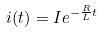Convert formula to latex. <formula><loc_0><loc_0><loc_500><loc_500>i ( t ) = I e ^ { - \frac { R } { L } t }</formula> 